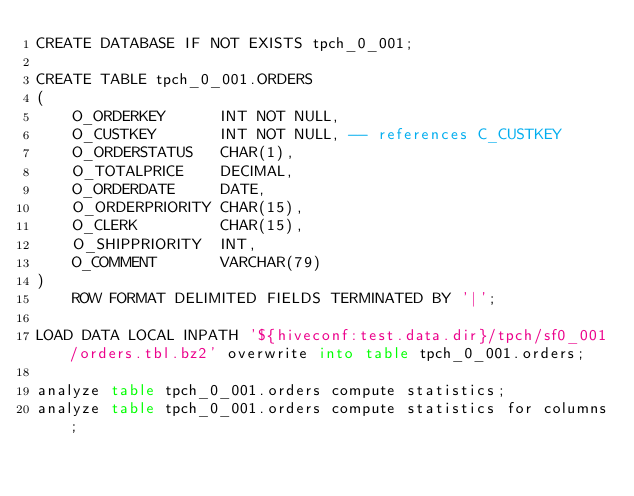Convert code to text. <code><loc_0><loc_0><loc_500><loc_500><_SQL_>CREATE DATABASE IF NOT EXISTS tpch_0_001;

CREATE TABLE tpch_0_001.ORDERS
(
    O_ORDERKEY      INT NOT NULL,
    O_CUSTKEY       INT NOT NULL, -- references C_CUSTKEY
    O_ORDERSTATUS   CHAR(1),
    O_TOTALPRICE    DECIMAL,
    O_ORDERDATE     DATE,
    O_ORDERPRIORITY CHAR(15),
    O_CLERK         CHAR(15),
    O_SHIPPRIORITY  INT,
    O_COMMENT       VARCHAR(79)
)
    ROW FORMAT DELIMITED FIELDS TERMINATED BY '|';

LOAD DATA LOCAL INPATH '${hiveconf:test.data.dir}/tpch/sf0_001/orders.tbl.bz2' overwrite into table tpch_0_001.orders;

analyze table tpch_0_001.orders compute statistics;
analyze table tpch_0_001.orders compute statistics for columns;
</code> 